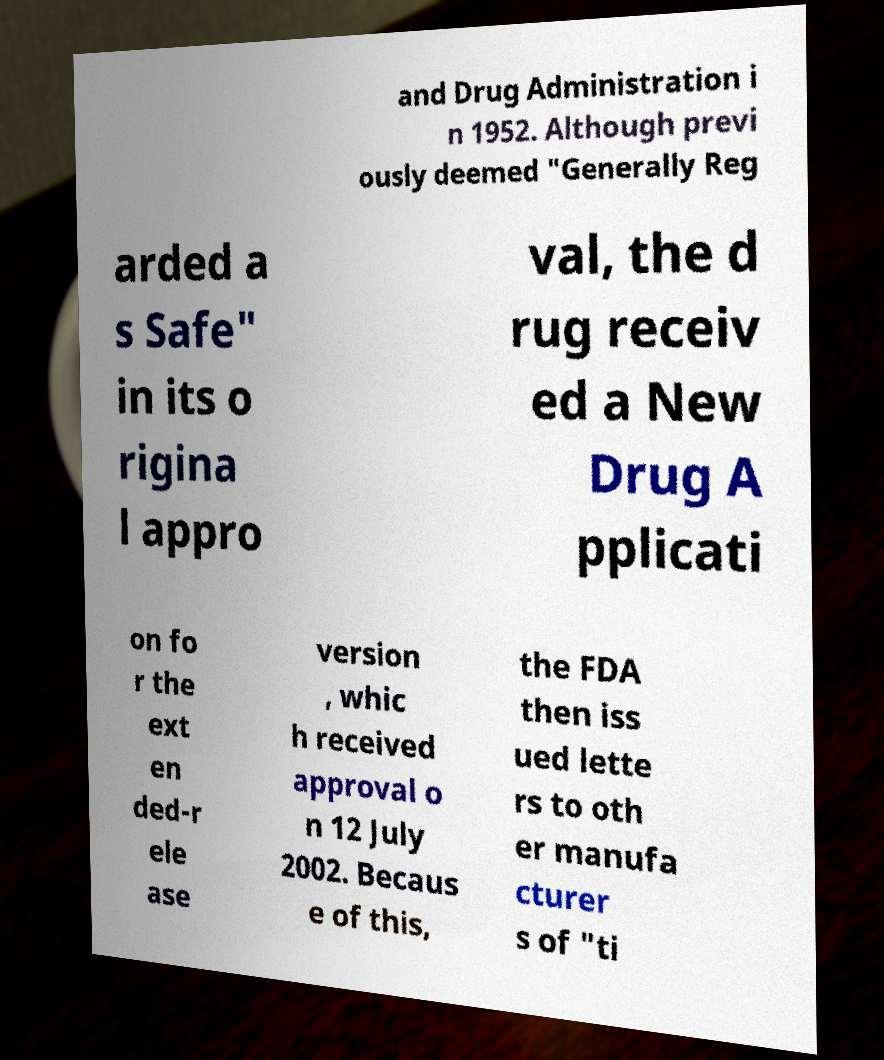Please read and relay the text visible in this image. What does it say? and Drug Administration i n 1952. Although previ ously deemed "Generally Reg arded a s Safe" in its o rigina l appro val, the d rug receiv ed a New Drug A pplicati on fo r the ext en ded-r ele ase version , whic h received approval o n 12 July 2002. Becaus e of this, the FDA then iss ued lette rs to oth er manufa cturer s of "ti 